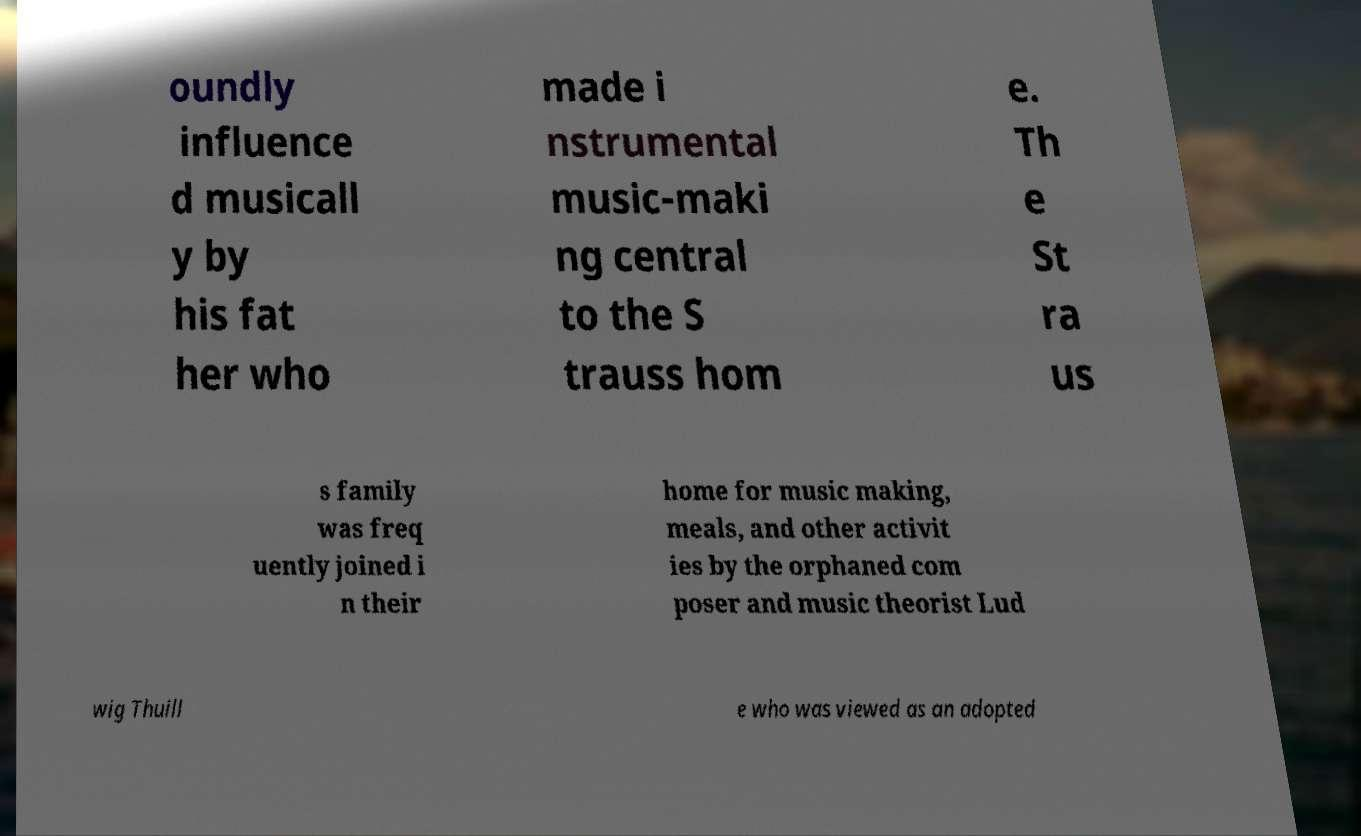Can you read and provide the text displayed in the image?This photo seems to have some interesting text. Can you extract and type it out for me? oundly influence d musicall y by his fat her who made i nstrumental music-maki ng central to the S trauss hom e. Th e St ra us s family was freq uently joined i n their home for music making, meals, and other activit ies by the orphaned com poser and music theorist Lud wig Thuill e who was viewed as an adopted 